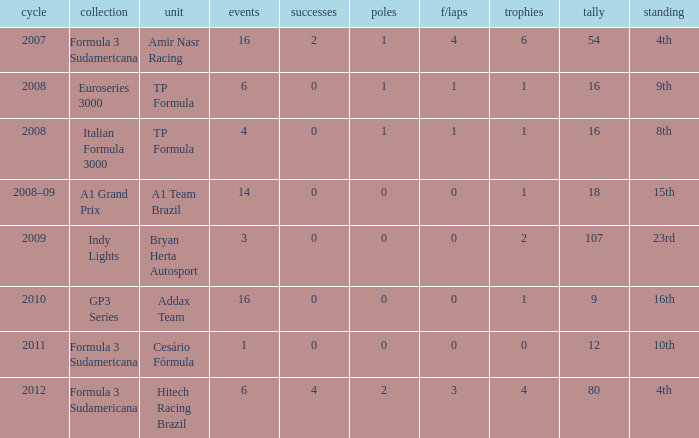What team did he compete for in the GP3 series? Addax Team. 